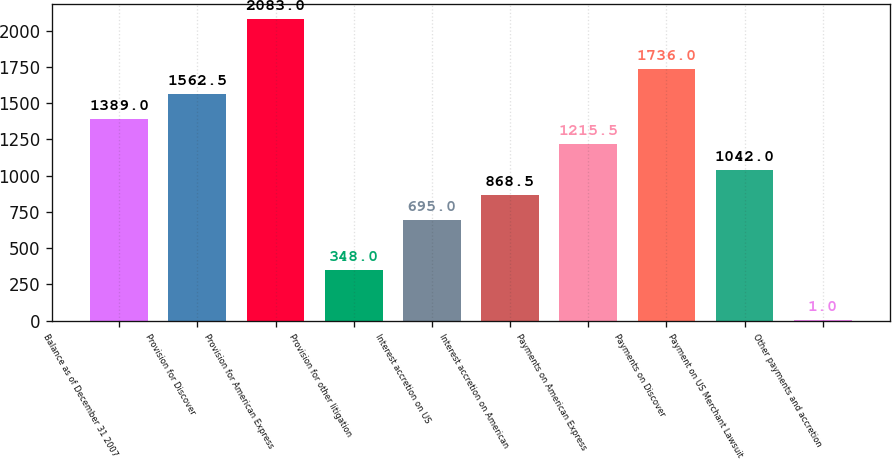<chart> <loc_0><loc_0><loc_500><loc_500><bar_chart><fcel>Balance as of December 31 2007<fcel>Provision for Discover<fcel>Provision for American Express<fcel>Provision for other litigation<fcel>Interest accretion on US<fcel>Interest accretion on American<fcel>Payments on American Express<fcel>Payments on Discover<fcel>Payment on US Merchant Lawsuit<fcel>Other payments and accretion<nl><fcel>1389<fcel>1562.5<fcel>2083<fcel>348<fcel>695<fcel>868.5<fcel>1215.5<fcel>1736<fcel>1042<fcel>1<nl></chart> 